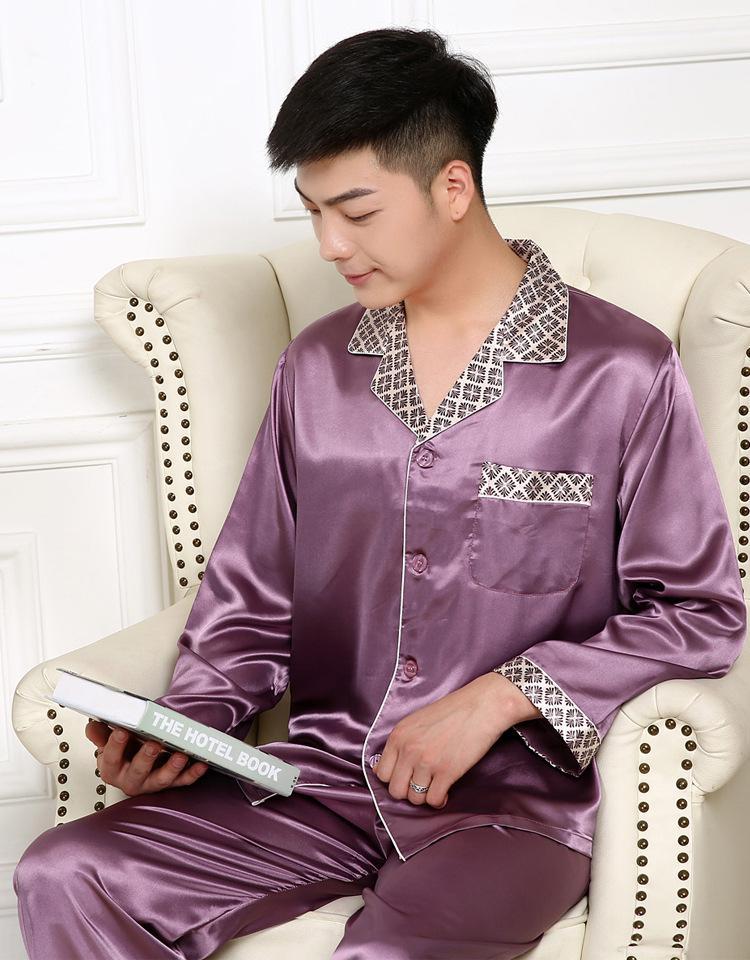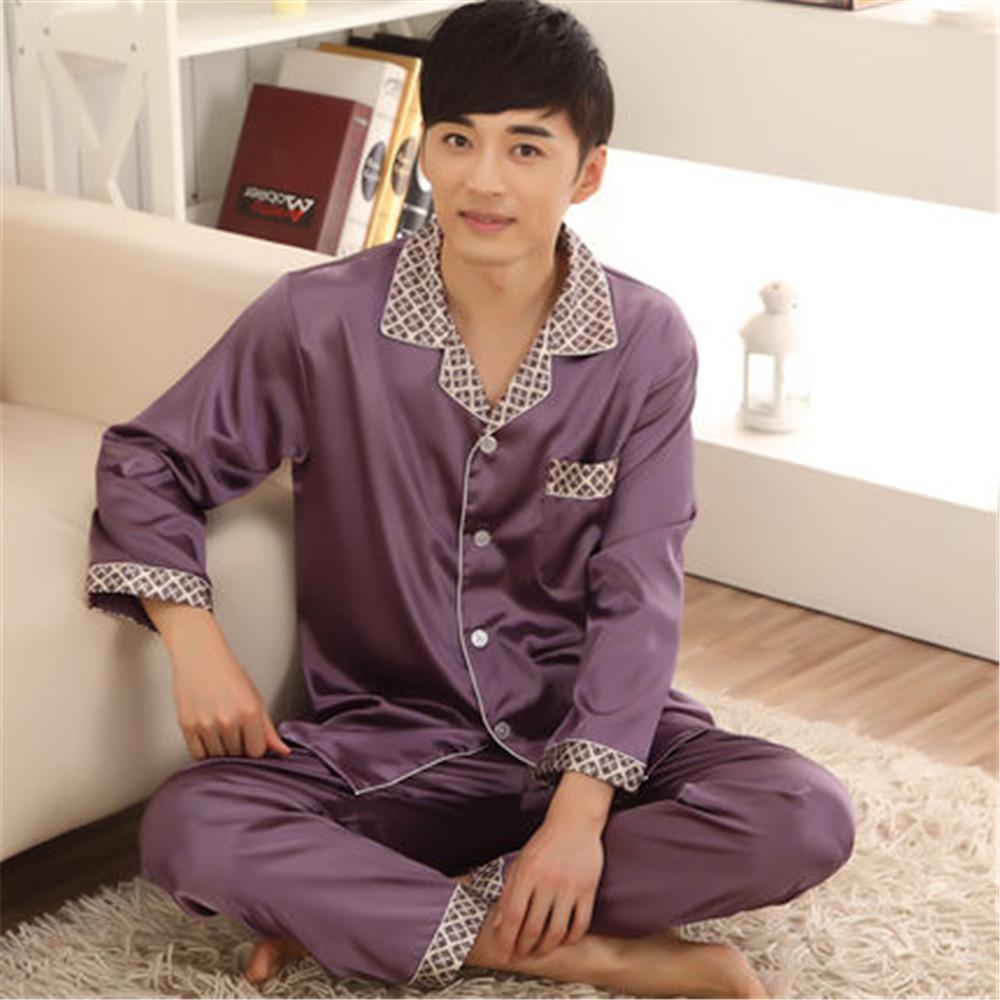The first image is the image on the left, the second image is the image on the right. Analyze the images presented: Is the assertion "There are no pieces of furniture in the background of these images." valid? Answer yes or no. No. The first image is the image on the left, the second image is the image on the right. Given the left and right images, does the statement "In one image, a man wearing solid color silky pajamas with cuffs on both shirt and pants is standing with one foot forward." hold true? Answer yes or no. No. 